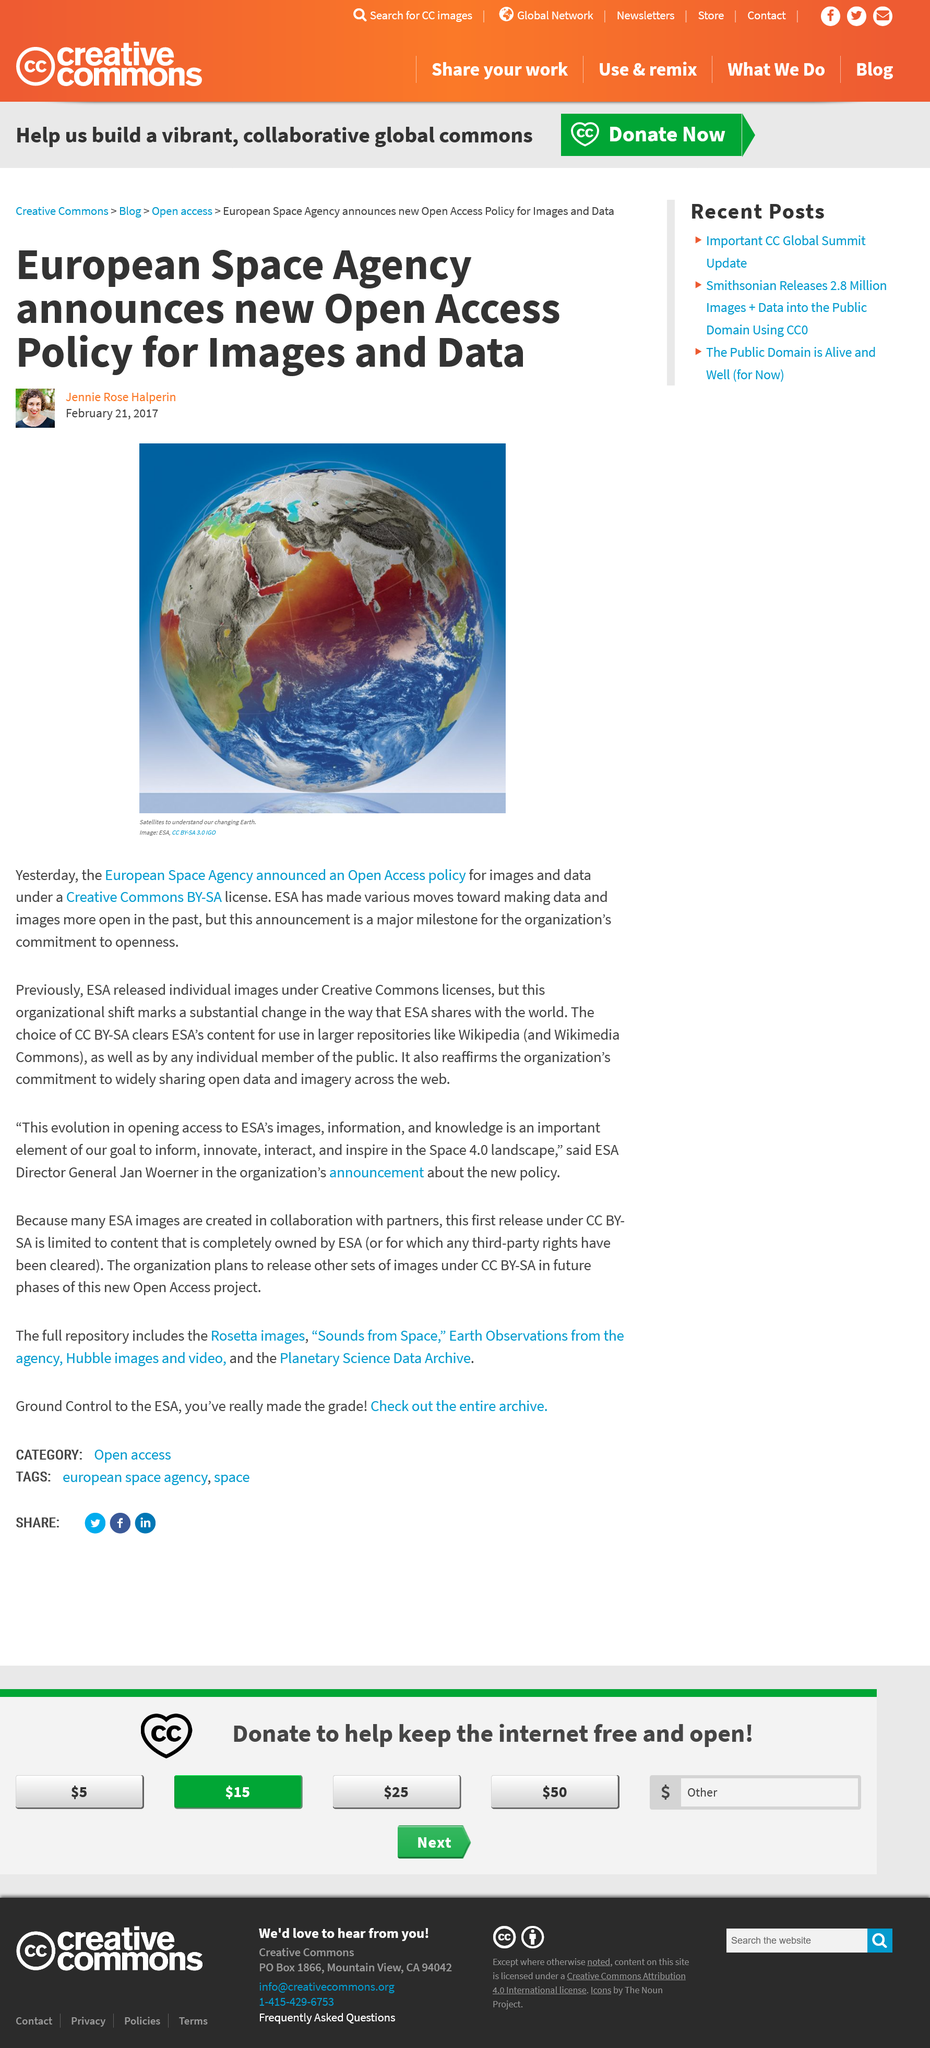Give some essential details in this illustration. The European Space Agency previously released images under the Creative Commons license. The European Space Agency will be announcing a new policy change. The author of this article is Jennie Rose Halperin. 